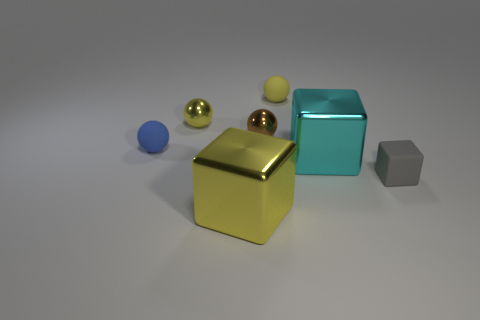How many yellow balls must be subtracted to get 1 yellow balls? 1 Subtract all gray blocks. How many yellow balls are left? 2 Subtract 1 balls. How many balls are left? 3 Subtract all blue balls. How many balls are left? 3 Subtract all brown spheres. How many spheres are left? 3 Add 2 large blue metal cylinders. How many objects exist? 9 Subtract all blue blocks. Subtract all red cylinders. How many blocks are left? 3 Subtract all blocks. How many objects are left? 4 Subtract 0 cyan balls. How many objects are left? 7 Subtract all purple matte spheres. Subtract all tiny blue things. How many objects are left? 6 